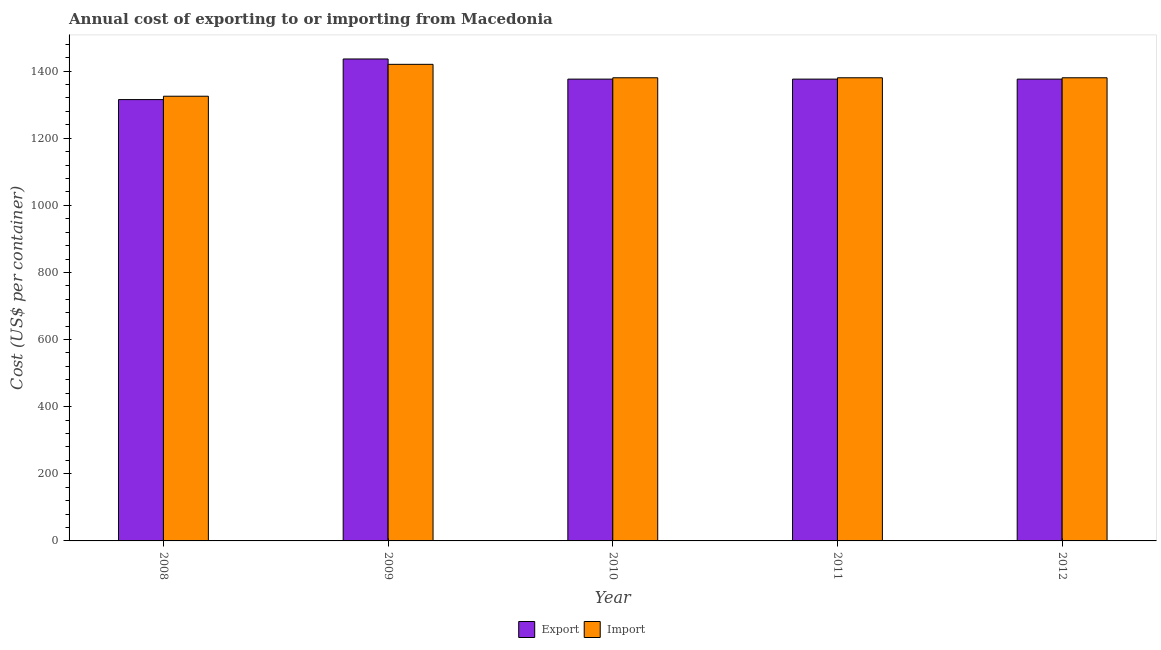How many groups of bars are there?
Ensure brevity in your answer.  5. Are the number of bars per tick equal to the number of legend labels?
Your answer should be compact. Yes. How many bars are there on the 4th tick from the left?
Keep it short and to the point. 2. What is the export cost in 2011?
Provide a short and direct response. 1376. Across all years, what is the maximum import cost?
Make the answer very short. 1420. Across all years, what is the minimum export cost?
Keep it short and to the point. 1315. In which year was the import cost maximum?
Your response must be concise. 2009. What is the total import cost in the graph?
Make the answer very short. 6885. What is the difference between the export cost in 2008 and that in 2009?
Keep it short and to the point. -121. What is the difference between the import cost in 2011 and the export cost in 2008?
Make the answer very short. 55. What is the average import cost per year?
Offer a terse response. 1377. What is the ratio of the export cost in 2009 to that in 2012?
Ensure brevity in your answer.  1.04. What is the difference between the highest and the second highest import cost?
Your answer should be very brief. 40. What is the difference between the highest and the lowest export cost?
Your answer should be very brief. 121. Is the sum of the export cost in 2009 and 2011 greater than the maximum import cost across all years?
Your answer should be compact. Yes. What does the 2nd bar from the left in 2010 represents?
Ensure brevity in your answer.  Import. What does the 1st bar from the right in 2011 represents?
Keep it short and to the point. Import. What is the difference between two consecutive major ticks on the Y-axis?
Offer a terse response. 200. Does the graph contain grids?
Your answer should be compact. No. How many legend labels are there?
Offer a very short reply. 2. How are the legend labels stacked?
Provide a short and direct response. Horizontal. What is the title of the graph?
Keep it short and to the point. Annual cost of exporting to or importing from Macedonia. What is the label or title of the X-axis?
Your answer should be compact. Year. What is the label or title of the Y-axis?
Your answer should be compact. Cost (US$ per container). What is the Cost (US$ per container) of Export in 2008?
Make the answer very short. 1315. What is the Cost (US$ per container) of Import in 2008?
Your answer should be compact. 1325. What is the Cost (US$ per container) in Export in 2009?
Give a very brief answer. 1436. What is the Cost (US$ per container) of Import in 2009?
Ensure brevity in your answer.  1420. What is the Cost (US$ per container) of Export in 2010?
Your answer should be very brief. 1376. What is the Cost (US$ per container) of Import in 2010?
Provide a short and direct response. 1380. What is the Cost (US$ per container) in Export in 2011?
Offer a very short reply. 1376. What is the Cost (US$ per container) in Import in 2011?
Make the answer very short. 1380. What is the Cost (US$ per container) in Export in 2012?
Your answer should be very brief. 1376. What is the Cost (US$ per container) of Import in 2012?
Provide a succinct answer. 1380. Across all years, what is the maximum Cost (US$ per container) in Export?
Offer a terse response. 1436. Across all years, what is the maximum Cost (US$ per container) of Import?
Your answer should be compact. 1420. Across all years, what is the minimum Cost (US$ per container) in Export?
Offer a terse response. 1315. Across all years, what is the minimum Cost (US$ per container) of Import?
Keep it short and to the point. 1325. What is the total Cost (US$ per container) in Export in the graph?
Provide a short and direct response. 6879. What is the total Cost (US$ per container) of Import in the graph?
Offer a very short reply. 6885. What is the difference between the Cost (US$ per container) in Export in 2008 and that in 2009?
Your answer should be compact. -121. What is the difference between the Cost (US$ per container) in Import in 2008 and that in 2009?
Provide a short and direct response. -95. What is the difference between the Cost (US$ per container) of Export in 2008 and that in 2010?
Provide a short and direct response. -61. What is the difference between the Cost (US$ per container) of Import in 2008 and that in 2010?
Your response must be concise. -55. What is the difference between the Cost (US$ per container) in Export in 2008 and that in 2011?
Give a very brief answer. -61. What is the difference between the Cost (US$ per container) of Import in 2008 and that in 2011?
Give a very brief answer. -55. What is the difference between the Cost (US$ per container) of Export in 2008 and that in 2012?
Offer a very short reply. -61. What is the difference between the Cost (US$ per container) in Import in 2008 and that in 2012?
Provide a short and direct response. -55. What is the difference between the Cost (US$ per container) in Export in 2009 and that in 2012?
Make the answer very short. 60. What is the difference between the Cost (US$ per container) in Export in 2010 and that in 2011?
Keep it short and to the point. 0. What is the difference between the Cost (US$ per container) in Export in 2010 and that in 2012?
Your answer should be compact. 0. What is the difference between the Cost (US$ per container) in Import in 2010 and that in 2012?
Your answer should be very brief. 0. What is the difference between the Cost (US$ per container) in Export in 2011 and that in 2012?
Your answer should be very brief. 0. What is the difference between the Cost (US$ per container) in Import in 2011 and that in 2012?
Offer a terse response. 0. What is the difference between the Cost (US$ per container) in Export in 2008 and the Cost (US$ per container) in Import in 2009?
Keep it short and to the point. -105. What is the difference between the Cost (US$ per container) of Export in 2008 and the Cost (US$ per container) of Import in 2010?
Your response must be concise. -65. What is the difference between the Cost (US$ per container) in Export in 2008 and the Cost (US$ per container) in Import in 2011?
Your response must be concise. -65. What is the difference between the Cost (US$ per container) of Export in 2008 and the Cost (US$ per container) of Import in 2012?
Make the answer very short. -65. What is the difference between the Cost (US$ per container) in Export in 2009 and the Cost (US$ per container) in Import in 2010?
Give a very brief answer. 56. What is the difference between the Cost (US$ per container) in Export in 2009 and the Cost (US$ per container) in Import in 2011?
Provide a succinct answer. 56. What is the average Cost (US$ per container) of Export per year?
Your response must be concise. 1375.8. What is the average Cost (US$ per container) of Import per year?
Your answer should be very brief. 1377. In the year 2009, what is the difference between the Cost (US$ per container) in Export and Cost (US$ per container) in Import?
Keep it short and to the point. 16. What is the ratio of the Cost (US$ per container) in Export in 2008 to that in 2009?
Give a very brief answer. 0.92. What is the ratio of the Cost (US$ per container) in Import in 2008 to that in 2009?
Provide a succinct answer. 0.93. What is the ratio of the Cost (US$ per container) of Export in 2008 to that in 2010?
Give a very brief answer. 0.96. What is the ratio of the Cost (US$ per container) of Import in 2008 to that in 2010?
Your answer should be compact. 0.96. What is the ratio of the Cost (US$ per container) in Export in 2008 to that in 2011?
Your response must be concise. 0.96. What is the ratio of the Cost (US$ per container) of Import in 2008 to that in 2011?
Offer a terse response. 0.96. What is the ratio of the Cost (US$ per container) of Export in 2008 to that in 2012?
Give a very brief answer. 0.96. What is the ratio of the Cost (US$ per container) in Import in 2008 to that in 2012?
Keep it short and to the point. 0.96. What is the ratio of the Cost (US$ per container) of Export in 2009 to that in 2010?
Provide a succinct answer. 1.04. What is the ratio of the Cost (US$ per container) of Export in 2009 to that in 2011?
Make the answer very short. 1.04. What is the ratio of the Cost (US$ per container) in Export in 2009 to that in 2012?
Offer a very short reply. 1.04. What is the ratio of the Cost (US$ per container) of Import in 2010 to that in 2011?
Give a very brief answer. 1. What is the ratio of the Cost (US$ per container) of Export in 2011 to that in 2012?
Keep it short and to the point. 1. What is the ratio of the Cost (US$ per container) of Import in 2011 to that in 2012?
Your answer should be compact. 1. What is the difference between the highest and the second highest Cost (US$ per container) of Export?
Offer a very short reply. 60. What is the difference between the highest and the lowest Cost (US$ per container) of Export?
Offer a terse response. 121. 